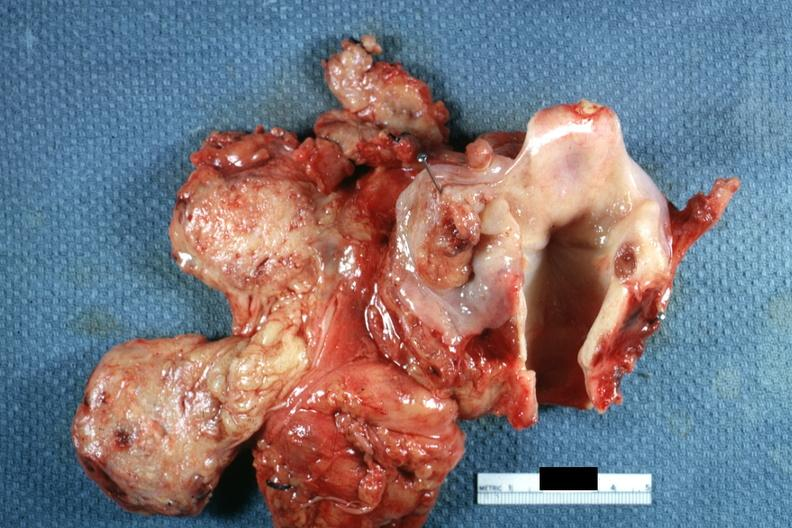what is present?
Answer the question using a single word or phrase. Squamous cell carcinoma 